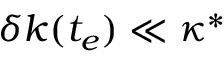<formula> <loc_0><loc_0><loc_500><loc_500>\delta k ( t _ { e } ) \ll \kappa ^ { * }</formula> 